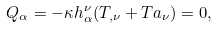<formula> <loc_0><loc_0><loc_500><loc_500>Q _ { \alpha } = - \kappa h _ { \alpha } ^ { \nu } ( T _ { , \nu } + T a _ { \nu } ) = 0 ,</formula> 